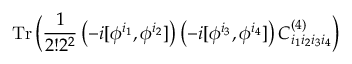Convert formula to latex. <formula><loc_0><loc_0><loc_500><loc_500>T r \, \left ( { \frac { 1 } { 2 ! 2 ^ { 2 } } } \left ( - i [ \phi ^ { i _ { 1 } } , \phi ^ { i _ { 2 } } ] \right ) \left ( - i [ \phi ^ { i _ { 3 } } , \phi ^ { i _ { 4 } } ] \right ) C _ { i _ { 1 } i _ { 2 } i _ { 3 } i _ { 4 } } ^ { ( 4 ) } \right )</formula> 